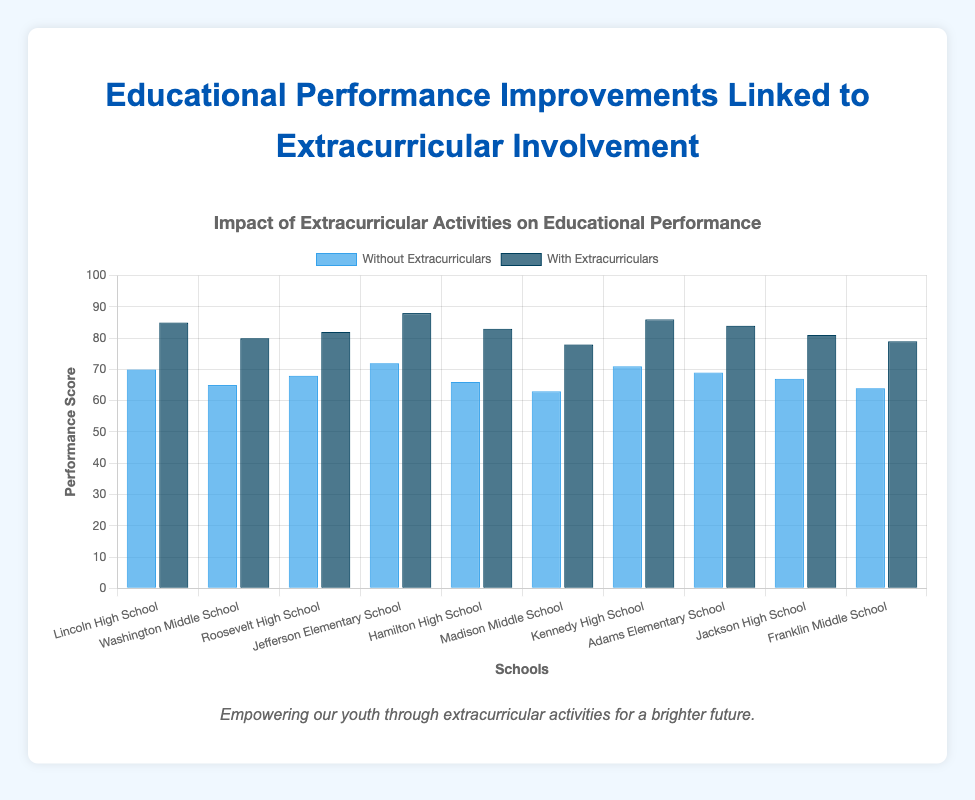Which school showed the highest improvement in performance with extracurricular activities? Among all the schools listed, Jefferson Elementary School showed the highest improvement. The difference between the performance scores with and without extracurriculars is 88 - 72 = 16.
Answer: Jefferson Elementary School What is the average performance score for schools without extracurricular activities? To find the average, sum the scores of all schools without extracurriculars and divide by the number of schools: (70 + 65 + 68 + 72 + 66 + 63 + 71 + 69 + 67 + 64)/10 = 675/10 = 67.5.
Answer: 67.5 What is the difference in performance scores with and without extracurriculars for Lincoln High School? For Lincoln High School, the performance score with extracurriculars is 85, and without extracurriculars is 70. The difference is 85 - 70 = 15.
Answer: 15 Which type of bar (color) represents performance scores with extracurricular activities? The bar that represents performance scores with extracurricular activities is visually described as dark blue in the chart.
Answer: Dark blue Compare the performance improvement between Washington Middle School and Madison Middle School. Which had a greater improvement? Washington Middle School improved from 65 to 80, which is an increase of 15 (80 - 65), while Madison Middle School improved from 63 to 78, which is also an increase of 15 (78 - 63). Both schools had the same improvement of 15 points.
Answer: Both had the same improvement How much higher is the performance score with extracurriculars at Kennedy High School compared to Hamilton High School? Kennedy High School has a score of 86 with extracurriculars, while Hamilton High School has 83. The difference is 86 - 83 = 3.
Answer: 3 Which school has the lowest performance score without extracurriculars? Madison Middle School has the lowest performance score without extracurriculars, which is 63.
Answer: Madison Middle School What is the average improvement in performance scores when extracurricular activities are included? Calculate the improvement for each school first, then divide the sum by the number of schools: (15 + 15 + 14 + 16 + 17 + 15 + 15 + 15 + 14 + 15)/10 = 151/10 = 15.1.
Answer: 15.1 How does the height of the bars for Adams Elementary School compare for performance with and without extracurriculars? The height of the bar representing performance with extracurriculars (dark blue) is noticeably taller than the one without extracurriculars (blue) for Adams Elementary School, indicating a significant improvement.
Answer: Taller What is the total performance score for all schools with extracurriculars? Summing up all the performance scores with extracurriculars: 85 + 80 + 82 + 88 + 83 + 78 + 86 + 84 + 81 + 79 = 836.
Answer: 836 